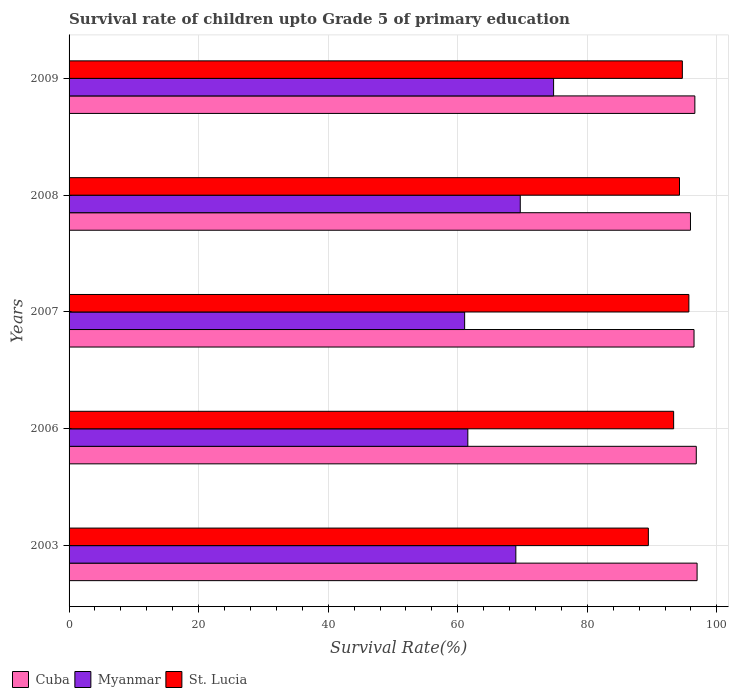How many different coloured bars are there?
Offer a very short reply. 3. Are the number of bars per tick equal to the number of legend labels?
Make the answer very short. Yes. Are the number of bars on each tick of the Y-axis equal?
Provide a succinct answer. Yes. What is the label of the 5th group of bars from the top?
Offer a terse response. 2003. In how many cases, is the number of bars for a given year not equal to the number of legend labels?
Keep it short and to the point. 0. What is the survival rate of children in Myanmar in 2007?
Keep it short and to the point. 61.06. Across all years, what is the maximum survival rate of children in St. Lucia?
Provide a succinct answer. 95.67. Across all years, what is the minimum survival rate of children in Cuba?
Your response must be concise. 95.92. In which year was the survival rate of children in St. Lucia maximum?
Provide a short and direct response. 2007. What is the total survival rate of children in Myanmar in the graph?
Your answer should be very brief. 336.02. What is the difference between the survival rate of children in Cuba in 2008 and that in 2009?
Give a very brief answer. -0.68. What is the difference between the survival rate of children in Cuba in 2009 and the survival rate of children in St. Lucia in 2007?
Offer a terse response. 0.92. What is the average survival rate of children in St. Lucia per year?
Offer a very short reply. 93.46. In the year 2006, what is the difference between the survival rate of children in St. Lucia and survival rate of children in Cuba?
Ensure brevity in your answer.  -3.49. What is the ratio of the survival rate of children in Cuba in 2003 to that in 2009?
Your response must be concise. 1. Is the survival rate of children in St. Lucia in 2006 less than that in 2009?
Offer a very short reply. Yes. Is the difference between the survival rate of children in St. Lucia in 2006 and 2008 greater than the difference between the survival rate of children in Cuba in 2006 and 2008?
Ensure brevity in your answer.  No. What is the difference between the highest and the second highest survival rate of children in Cuba?
Give a very brief answer. 0.13. What is the difference between the highest and the lowest survival rate of children in Cuba?
Give a very brief answer. 1.02. In how many years, is the survival rate of children in Myanmar greater than the average survival rate of children in Myanmar taken over all years?
Your answer should be very brief. 3. What does the 3rd bar from the top in 2007 represents?
Provide a succinct answer. Cuba. What does the 1st bar from the bottom in 2007 represents?
Keep it short and to the point. Cuba. Is it the case that in every year, the sum of the survival rate of children in Myanmar and survival rate of children in Cuba is greater than the survival rate of children in St. Lucia?
Make the answer very short. Yes. How many bars are there?
Provide a short and direct response. 15. How many years are there in the graph?
Your answer should be very brief. 5. What is the difference between two consecutive major ticks on the X-axis?
Your response must be concise. 20. Does the graph contain any zero values?
Provide a succinct answer. No. Does the graph contain grids?
Offer a terse response. Yes. Where does the legend appear in the graph?
Provide a short and direct response. Bottom left. How many legend labels are there?
Your answer should be compact. 3. How are the legend labels stacked?
Ensure brevity in your answer.  Horizontal. What is the title of the graph?
Your answer should be very brief. Survival rate of children upto Grade 5 of primary education. Does "Maldives" appear as one of the legend labels in the graph?
Offer a very short reply. No. What is the label or title of the X-axis?
Your answer should be very brief. Survival Rate(%). What is the label or title of the Y-axis?
Your answer should be very brief. Years. What is the Survival Rate(%) in Cuba in 2003?
Your response must be concise. 96.94. What is the Survival Rate(%) in Myanmar in 2003?
Your answer should be compact. 68.96. What is the Survival Rate(%) of St. Lucia in 2003?
Your response must be concise. 89.42. What is the Survival Rate(%) of Cuba in 2006?
Keep it short and to the point. 96.82. What is the Survival Rate(%) of Myanmar in 2006?
Provide a short and direct response. 61.55. What is the Survival Rate(%) of St. Lucia in 2006?
Your answer should be compact. 93.32. What is the Survival Rate(%) of Cuba in 2007?
Ensure brevity in your answer.  96.47. What is the Survival Rate(%) of Myanmar in 2007?
Provide a succinct answer. 61.06. What is the Survival Rate(%) in St. Lucia in 2007?
Offer a terse response. 95.67. What is the Survival Rate(%) in Cuba in 2008?
Offer a terse response. 95.92. What is the Survival Rate(%) in Myanmar in 2008?
Your answer should be compact. 69.65. What is the Survival Rate(%) of St. Lucia in 2008?
Keep it short and to the point. 94.23. What is the Survival Rate(%) of Cuba in 2009?
Offer a terse response. 96.6. What is the Survival Rate(%) in Myanmar in 2009?
Provide a short and direct response. 74.79. What is the Survival Rate(%) of St. Lucia in 2009?
Provide a succinct answer. 94.67. Across all years, what is the maximum Survival Rate(%) of Cuba?
Offer a very short reply. 96.94. Across all years, what is the maximum Survival Rate(%) of Myanmar?
Make the answer very short. 74.79. Across all years, what is the maximum Survival Rate(%) of St. Lucia?
Your answer should be compact. 95.67. Across all years, what is the minimum Survival Rate(%) in Cuba?
Provide a short and direct response. 95.92. Across all years, what is the minimum Survival Rate(%) in Myanmar?
Provide a succinct answer. 61.06. Across all years, what is the minimum Survival Rate(%) of St. Lucia?
Ensure brevity in your answer.  89.42. What is the total Survival Rate(%) of Cuba in the graph?
Make the answer very short. 482.75. What is the total Survival Rate(%) in Myanmar in the graph?
Give a very brief answer. 336.02. What is the total Survival Rate(%) in St. Lucia in the graph?
Offer a very short reply. 467.31. What is the difference between the Survival Rate(%) of Cuba in 2003 and that in 2006?
Keep it short and to the point. 0.13. What is the difference between the Survival Rate(%) in Myanmar in 2003 and that in 2006?
Offer a very short reply. 7.41. What is the difference between the Survival Rate(%) in St. Lucia in 2003 and that in 2006?
Make the answer very short. -3.9. What is the difference between the Survival Rate(%) in Cuba in 2003 and that in 2007?
Make the answer very short. 0.47. What is the difference between the Survival Rate(%) of Myanmar in 2003 and that in 2007?
Offer a very short reply. 7.9. What is the difference between the Survival Rate(%) in St. Lucia in 2003 and that in 2007?
Ensure brevity in your answer.  -6.26. What is the difference between the Survival Rate(%) of Cuba in 2003 and that in 2008?
Your response must be concise. 1.02. What is the difference between the Survival Rate(%) in Myanmar in 2003 and that in 2008?
Provide a short and direct response. -0.68. What is the difference between the Survival Rate(%) in St. Lucia in 2003 and that in 2008?
Provide a succinct answer. -4.81. What is the difference between the Survival Rate(%) of Cuba in 2003 and that in 2009?
Your response must be concise. 0.34. What is the difference between the Survival Rate(%) in Myanmar in 2003 and that in 2009?
Provide a short and direct response. -5.83. What is the difference between the Survival Rate(%) of St. Lucia in 2003 and that in 2009?
Give a very brief answer. -5.25. What is the difference between the Survival Rate(%) in Cuba in 2006 and that in 2007?
Keep it short and to the point. 0.35. What is the difference between the Survival Rate(%) in Myanmar in 2006 and that in 2007?
Your response must be concise. 0.49. What is the difference between the Survival Rate(%) of St. Lucia in 2006 and that in 2007?
Provide a succinct answer. -2.35. What is the difference between the Survival Rate(%) in Cuba in 2006 and that in 2008?
Your response must be concise. 0.9. What is the difference between the Survival Rate(%) of Myanmar in 2006 and that in 2008?
Give a very brief answer. -8.09. What is the difference between the Survival Rate(%) in St. Lucia in 2006 and that in 2008?
Give a very brief answer. -0.9. What is the difference between the Survival Rate(%) in Cuba in 2006 and that in 2009?
Provide a succinct answer. 0.22. What is the difference between the Survival Rate(%) of Myanmar in 2006 and that in 2009?
Your answer should be compact. -13.24. What is the difference between the Survival Rate(%) of St. Lucia in 2006 and that in 2009?
Ensure brevity in your answer.  -1.34. What is the difference between the Survival Rate(%) in Cuba in 2007 and that in 2008?
Your response must be concise. 0.55. What is the difference between the Survival Rate(%) in Myanmar in 2007 and that in 2008?
Keep it short and to the point. -8.59. What is the difference between the Survival Rate(%) of St. Lucia in 2007 and that in 2008?
Provide a short and direct response. 1.45. What is the difference between the Survival Rate(%) in Cuba in 2007 and that in 2009?
Your answer should be compact. -0.13. What is the difference between the Survival Rate(%) of Myanmar in 2007 and that in 2009?
Provide a short and direct response. -13.73. What is the difference between the Survival Rate(%) in St. Lucia in 2007 and that in 2009?
Your response must be concise. 1.01. What is the difference between the Survival Rate(%) of Cuba in 2008 and that in 2009?
Your response must be concise. -0.68. What is the difference between the Survival Rate(%) in Myanmar in 2008 and that in 2009?
Provide a short and direct response. -5.15. What is the difference between the Survival Rate(%) of St. Lucia in 2008 and that in 2009?
Keep it short and to the point. -0.44. What is the difference between the Survival Rate(%) of Cuba in 2003 and the Survival Rate(%) of Myanmar in 2006?
Keep it short and to the point. 35.39. What is the difference between the Survival Rate(%) of Cuba in 2003 and the Survival Rate(%) of St. Lucia in 2006?
Your answer should be very brief. 3.62. What is the difference between the Survival Rate(%) in Myanmar in 2003 and the Survival Rate(%) in St. Lucia in 2006?
Your response must be concise. -24.36. What is the difference between the Survival Rate(%) of Cuba in 2003 and the Survival Rate(%) of Myanmar in 2007?
Offer a very short reply. 35.88. What is the difference between the Survival Rate(%) of Cuba in 2003 and the Survival Rate(%) of St. Lucia in 2007?
Your answer should be compact. 1.27. What is the difference between the Survival Rate(%) in Myanmar in 2003 and the Survival Rate(%) in St. Lucia in 2007?
Ensure brevity in your answer.  -26.71. What is the difference between the Survival Rate(%) of Cuba in 2003 and the Survival Rate(%) of Myanmar in 2008?
Keep it short and to the point. 27.3. What is the difference between the Survival Rate(%) in Cuba in 2003 and the Survival Rate(%) in St. Lucia in 2008?
Offer a terse response. 2.72. What is the difference between the Survival Rate(%) in Myanmar in 2003 and the Survival Rate(%) in St. Lucia in 2008?
Keep it short and to the point. -25.26. What is the difference between the Survival Rate(%) of Cuba in 2003 and the Survival Rate(%) of Myanmar in 2009?
Make the answer very short. 22.15. What is the difference between the Survival Rate(%) of Cuba in 2003 and the Survival Rate(%) of St. Lucia in 2009?
Give a very brief answer. 2.28. What is the difference between the Survival Rate(%) in Myanmar in 2003 and the Survival Rate(%) in St. Lucia in 2009?
Your answer should be very brief. -25.7. What is the difference between the Survival Rate(%) in Cuba in 2006 and the Survival Rate(%) in Myanmar in 2007?
Your response must be concise. 35.76. What is the difference between the Survival Rate(%) of Cuba in 2006 and the Survival Rate(%) of St. Lucia in 2007?
Make the answer very short. 1.14. What is the difference between the Survival Rate(%) in Myanmar in 2006 and the Survival Rate(%) in St. Lucia in 2007?
Your answer should be compact. -34.12. What is the difference between the Survival Rate(%) in Cuba in 2006 and the Survival Rate(%) in Myanmar in 2008?
Your answer should be compact. 27.17. What is the difference between the Survival Rate(%) in Cuba in 2006 and the Survival Rate(%) in St. Lucia in 2008?
Make the answer very short. 2.59. What is the difference between the Survival Rate(%) of Myanmar in 2006 and the Survival Rate(%) of St. Lucia in 2008?
Provide a short and direct response. -32.67. What is the difference between the Survival Rate(%) of Cuba in 2006 and the Survival Rate(%) of Myanmar in 2009?
Give a very brief answer. 22.02. What is the difference between the Survival Rate(%) in Cuba in 2006 and the Survival Rate(%) in St. Lucia in 2009?
Ensure brevity in your answer.  2.15. What is the difference between the Survival Rate(%) of Myanmar in 2006 and the Survival Rate(%) of St. Lucia in 2009?
Offer a terse response. -33.11. What is the difference between the Survival Rate(%) in Cuba in 2007 and the Survival Rate(%) in Myanmar in 2008?
Your response must be concise. 26.82. What is the difference between the Survival Rate(%) in Cuba in 2007 and the Survival Rate(%) in St. Lucia in 2008?
Offer a very short reply. 2.24. What is the difference between the Survival Rate(%) in Myanmar in 2007 and the Survival Rate(%) in St. Lucia in 2008?
Give a very brief answer. -33.17. What is the difference between the Survival Rate(%) in Cuba in 2007 and the Survival Rate(%) in Myanmar in 2009?
Provide a short and direct response. 21.68. What is the difference between the Survival Rate(%) of Cuba in 2007 and the Survival Rate(%) of St. Lucia in 2009?
Make the answer very short. 1.8. What is the difference between the Survival Rate(%) in Myanmar in 2007 and the Survival Rate(%) in St. Lucia in 2009?
Your answer should be compact. -33.61. What is the difference between the Survival Rate(%) of Cuba in 2008 and the Survival Rate(%) of Myanmar in 2009?
Keep it short and to the point. 21.13. What is the difference between the Survival Rate(%) in Cuba in 2008 and the Survival Rate(%) in St. Lucia in 2009?
Offer a very short reply. 1.25. What is the difference between the Survival Rate(%) in Myanmar in 2008 and the Survival Rate(%) in St. Lucia in 2009?
Ensure brevity in your answer.  -25.02. What is the average Survival Rate(%) in Cuba per year?
Offer a very short reply. 96.55. What is the average Survival Rate(%) of Myanmar per year?
Ensure brevity in your answer.  67.2. What is the average Survival Rate(%) of St. Lucia per year?
Give a very brief answer. 93.46. In the year 2003, what is the difference between the Survival Rate(%) in Cuba and Survival Rate(%) in Myanmar?
Your answer should be very brief. 27.98. In the year 2003, what is the difference between the Survival Rate(%) in Cuba and Survival Rate(%) in St. Lucia?
Keep it short and to the point. 7.52. In the year 2003, what is the difference between the Survival Rate(%) in Myanmar and Survival Rate(%) in St. Lucia?
Make the answer very short. -20.45. In the year 2006, what is the difference between the Survival Rate(%) in Cuba and Survival Rate(%) in Myanmar?
Offer a terse response. 35.26. In the year 2006, what is the difference between the Survival Rate(%) in Cuba and Survival Rate(%) in St. Lucia?
Make the answer very short. 3.49. In the year 2006, what is the difference between the Survival Rate(%) in Myanmar and Survival Rate(%) in St. Lucia?
Your answer should be very brief. -31.77. In the year 2007, what is the difference between the Survival Rate(%) of Cuba and Survival Rate(%) of Myanmar?
Offer a terse response. 35.41. In the year 2007, what is the difference between the Survival Rate(%) in Cuba and Survival Rate(%) in St. Lucia?
Keep it short and to the point. 0.8. In the year 2007, what is the difference between the Survival Rate(%) in Myanmar and Survival Rate(%) in St. Lucia?
Your answer should be compact. -34.61. In the year 2008, what is the difference between the Survival Rate(%) of Cuba and Survival Rate(%) of Myanmar?
Keep it short and to the point. 26.27. In the year 2008, what is the difference between the Survival Rate(%) in Cuba and Survival Rate(%) in St. Lucia?
Offer a very short reply. 1.69. In the year 2008, what is the difference between the Survival Rate(%) of Myanmar and Survival Rate(%) of St. Lucia?
Offer a very short reply. -24.58. In the year 2009, what is the difference between the Survival Rate(%) in Cuba and Survival Rate(%) in Myanmar?
Provide a short and direct response. 21.81. In the year 2009, what is the difference between the Survival Rate(%) of Cuba and Survival Rate(%) of St. Lucia?
Your response must be concise. 1.93. In the year 2009, what is the difference between the Survival Rate(%) in Myanmar and Survival Rate(%) in St. Lucia?
Keep it short and to the point. -19.87. What is the ratio of the Survival Rate(%) of Myanmar in 2003 to that in 2006?
Offer a very short reply. 1.12. What is the ratio of the Survival Rate(%) of St. Lucia in 2003 to that in 2006?
Ensure brevity in your answer.  0.96. What is the ratio of the Survival Rate(%) in Myanmar in 2003 to that in 2007?
Provide a short and direct response. 1.13. What is the ratio of the Survival Rate(%) of St. Lucia in 2003 to that in 2007?
Your answer should be very brief. 0.93. What is the ratio of the Survival Rate(%) of Cuba in 2003 to that in 2008?
Ensure brevity in your answer.  1.01. What is the ratio of the Survival Rate(%) in Myanmar in 2003 to that in 2008?
Make the answer very short. 0.99. What is the ratio of the Survival Rate(%) of St. Lucia in 2003 to that in 2008?
Your response must be concise. 0.95. What is the ratio of the Survival Rate(%) in Cuba in 2003 to that in 2009?
Your response must be concise. 1. What is the ratio of the Survival Rate(%) of Myanmar in 2003 to that in 2009?
Your response must be concise. 0.92. What is the ratio of the Survival Rate(%) in St. Lucia in 2003 to that in 2009?
Offer a terse response. 0.94. What is the ratio of the Survival Rate(%) of Myanmar in 2006 to that in 2007?
Your answer should be very brief. 1.01. What is the ratio of the Survival Rate(%) in St. Lucia in 2006 to that in 2007?
Give a very brief answer. 0.98. What is the ratio of the Survival Rate(%) of Cuba in 2006 to that in 2008?
Ensure brevity in your answer.  1.01. What is the ratio of the Survival Rate(%) in Myanmar in 2006 to that in 2008?
Give a very brief answer. 0.88. What is the ratio of the Survival Rate(%) of Cuba in 2006 to that in 2009?
Give a very brief answer. 1. What is the ratio of the Survival Rate(%) of Myanmar in 2006 to that in 2009?
Make the answer very short. 0.82. What is the ratio of the Survival Rate(%) of St. Lucia in 2006 to that in 2009?
Your response must be concise. 0.99. What is the ratio of the Survival Rate(%) of Cuba in 2007 to that in 2008?
Your answer should be very brief. 1.01. What is the ratio of the Survival Rate(%) in Myanmar in 2007 to that in 2008?
Provide a succinct answer. 0.88. What is the ratio of the Survival Rate(%) in St. Lucia in 2007 to that in 2008?
Make the answer very short. 1.02. What is the ratio of the Survival Rate(%) in Myanmar in 2007 to that in 2009?
Keep it short and to the point. 0.82. What is the ratio of the Survival Rate(%) in St. Lucia in 2007 to that in 2009?
Offer a terse response. 1.01. What is the ratio of the Survival Rate(%) in Cuba in 2008 to that in 2009?
Your answer should be compact. 0.99. What is the ratio of the Survival Rate(%) of Myanmar in 2008 to that in 2009?
Offer a terse response. 0.93. What is the difference between the highest and the second highest Survival Rate(%) of Cuba?
Your answer should be very brief. 0.13. What is the difference between the highest and the second highest Survival Rate(%) in Myanmar?
Give a very brief answer. 5.15. What is the difference between the highest and the second highest Survival Rate(%) in St. Lucia?
Ensure brevity in your answer.  1.01. What is the difference between the highest and the lowest Survival Rate(%) of Cuba?
Your response must be concise. 1.02. What is the difference between the highest and the lowest Survival Rate(%) of Myanmar?
Give a very brief answer. 13.73. What is the difference between the highest and the lowest Survival Rate(%) of St. Lucia?
Ensure brevity in your answer.  6.26. 